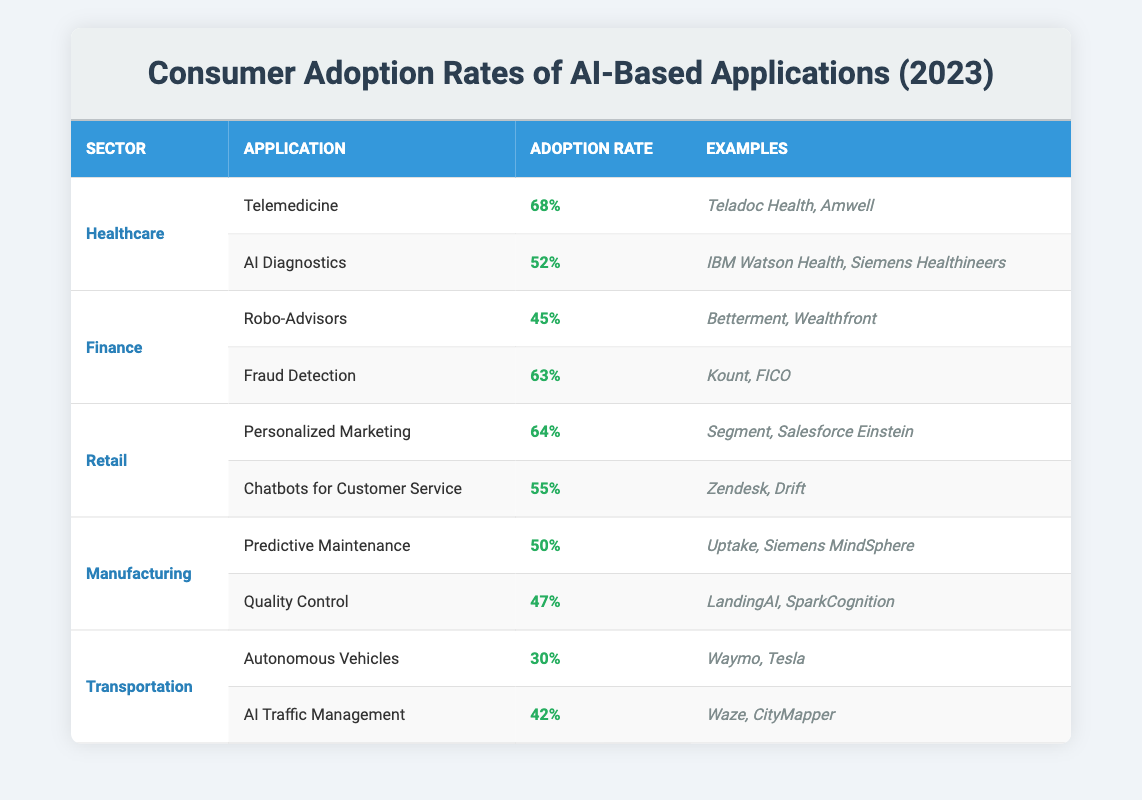What is the adoption rate for Telemedicine in the Healthcare sector? The table states that the adoption rate for Telemedicine under the Healthcare sector is 68%. This is the value listed in the corresponding cell of the table.
Answer: 68% Which application in the Finance sector has a higher adoption rate, Robo-Advisors or Fraud Detection? The table shows that Robo-Advisors have an adoption rate of 45%, whereas Fraud Detection has an adoption rate of 63%. Therefore, Fraud Detection has a higher adoption rate because 63% is greater than 45%.
Answer: Fraud Detection What is the average adoption rate of AI applications in the Transportation sector? The Transportation sector has two applications: Autonomous Vehicles at 30% and AI Traffic Management at 42%. To find the average, we sum the rates (30 + 42 = 72) and divide by the number of applications, which is 2. Thus, the average is 72/2 = 36%.
Answer: 36% Is it true that the Retail sector has an adoption rate higher than 60% for any AI application? Looking at the Retail sector, Personalized Marketing has an adoption rate of 64%, which is above 60%. Therefore, the statement is true as there is at least one application with an adoption rate higher than 60%.
Answer: Yes What is the difference between the highest and lowest adoption rates across all sectors? The highest adoption rate is 68% for Telemedicine, and the lowest is 30% for Autonomous Vehicles. To find the difference, we subtract the lowest from the highest: 68 - 30 = 38%.
Answer: 38% Which sector has the most applications listed in the table? The table contains applications listed for five sectors: Healthcare, Finance, Retail, Manufacturing, and Transportation. Each sector has two applications, so all sectors have the same number of applications (two). Thus, there is no sector with the most applications.
Answer: None Are there any sectors where the adoption rates for both applications are above 50%? The Healthcare sector has Telemedicine at 68% and AI Diagnostics at 52%, both above 50%. Additionally, the Finance sector has Fraud Detection at 63% and Robo-Advisors at 45%, which only has one application above 50%. Thus, there are sectors with both applications above 50%.
Answer: Yes Which AI application has the lowest adoption rate and what is that rate? The Autonomous Vehicles application in the Transportation sector has the lowest adoption rate at 30%, as indicated in the table. Therefore, this application has the lowest value.
Answer: Autonomous Vehicles at 30% 